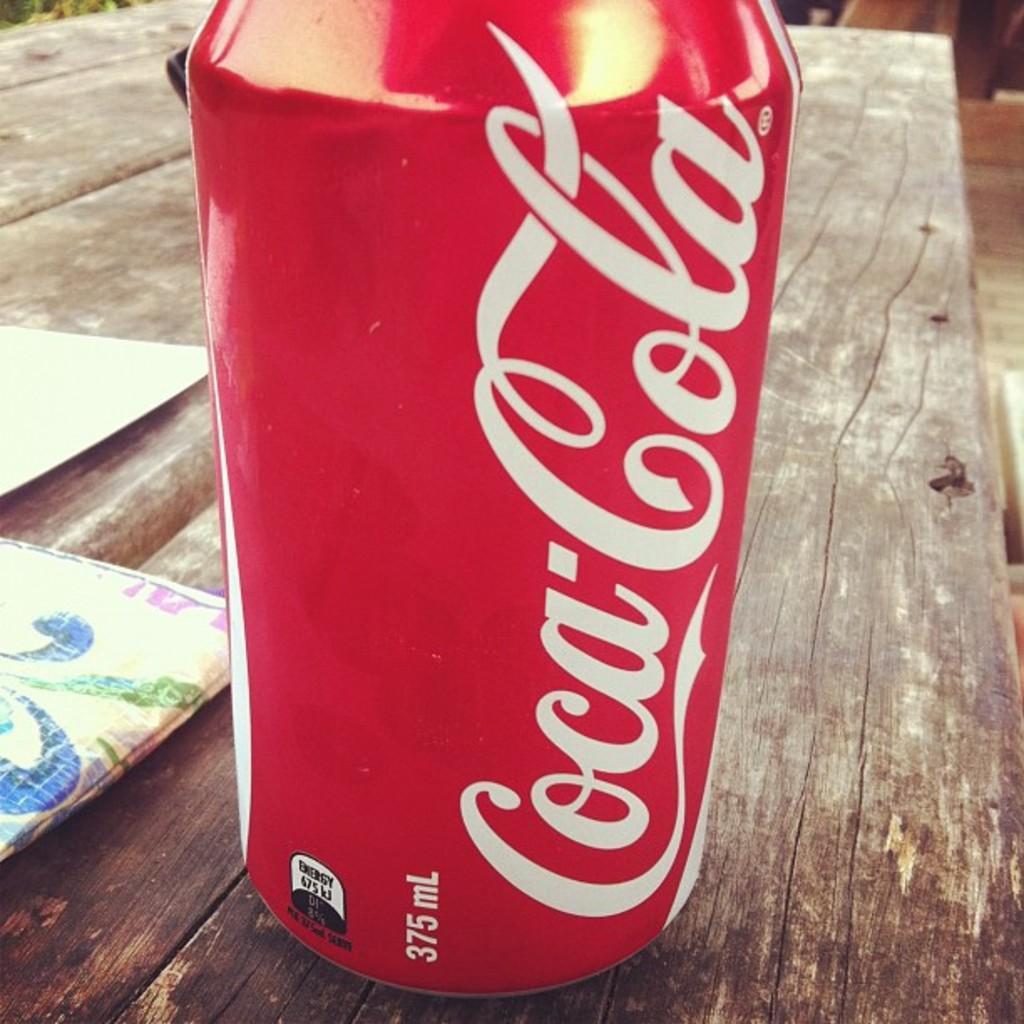What is the brand of soda?
Ensure brevity in your answer.  Coca cola. How many ml is this?
Provide a succinct answer. 375. 